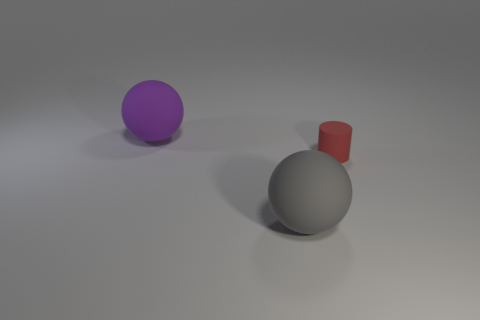Add 2 red metallic cylinders. How many objects exist? 5 Subtract all cylinders. How many objects are left? 2 Add 1 tiny matte things. How many tiny matte things are left? 2 Add 1 small red cylinders. How many small red cylinders exist? 2 Subtract 0 yellow blocks. How many objects are left? 3 Subtract all small green shiny balls. Subtract all big rubber things. How many objects are left? 1 